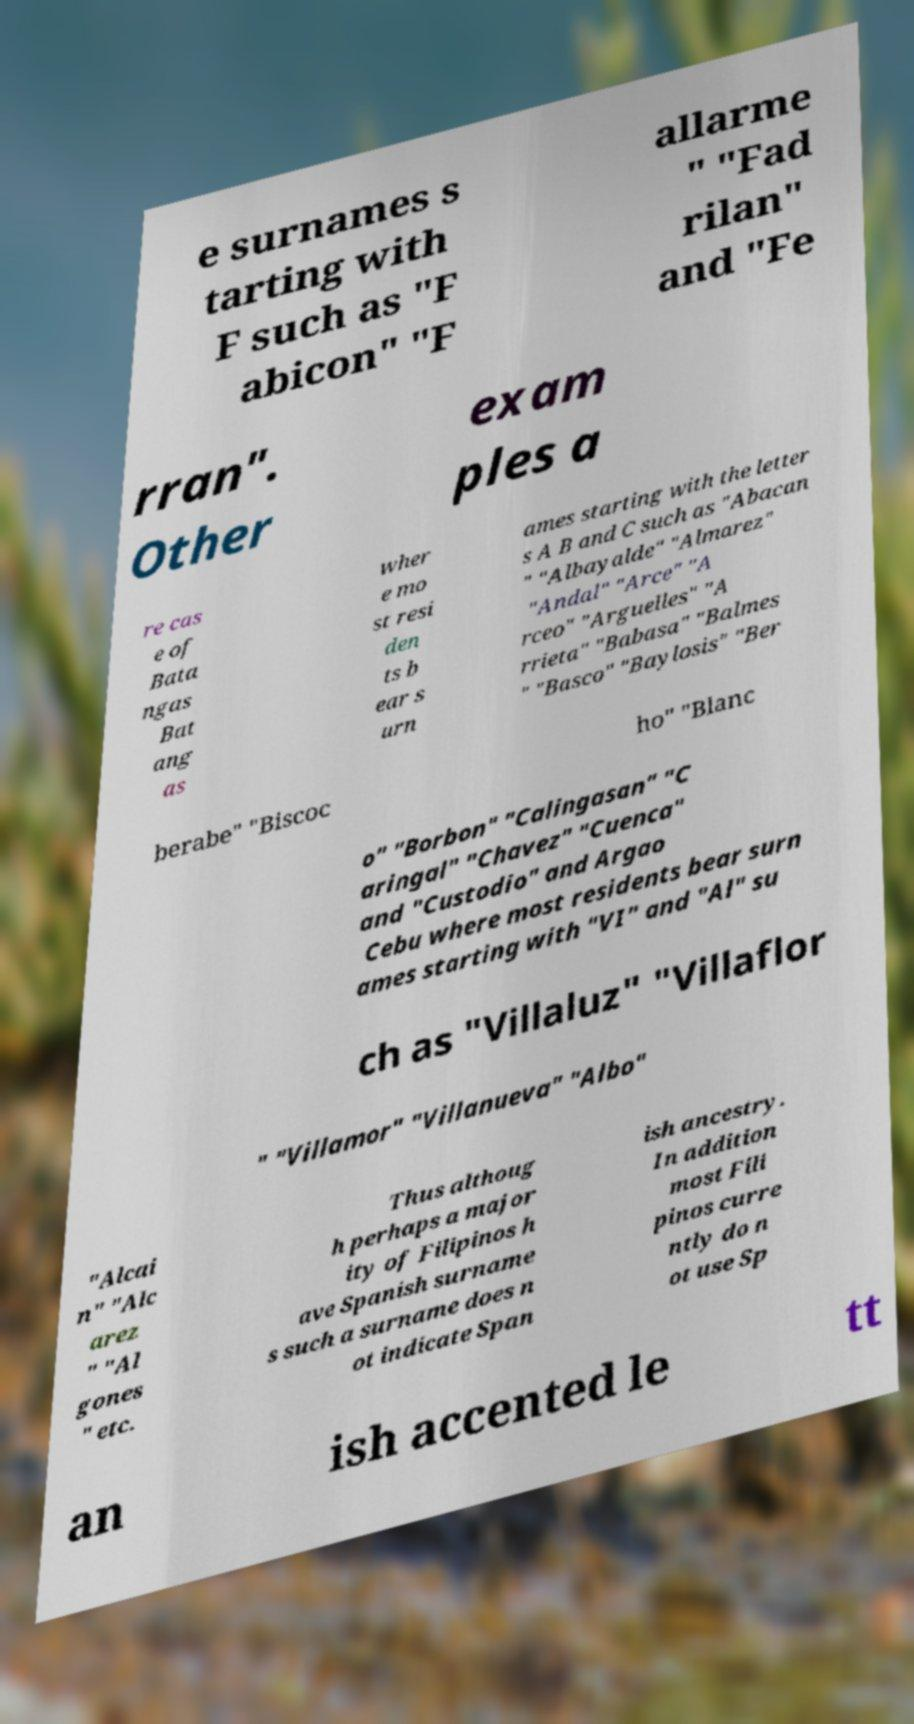For documentation purposes, I need the text within this image transcribed. Could you provide that? e surnames s tarting with F such as "F abicon" "F allarme " "Fad rilan" and "Fe rran". Other exam ples a re cas e of Bata ngas Bat ang as wher e mo st resi den ts b ear s urn ames starting with the letter s A B and C such as "Abacan " "Albayalde" "Almarez" "Andal" "Arce" "A rceo" "Arguelles" "A rrieta" "Babasa" "Balmes " "Basco" "Baylosis" "Ber berabe" "Biscoc ho" "Blanc o" "Borbon" "Calingasan" "C aringal" "Chavez" "Cuenca" and "Custodio" and Argao Cebu where most residents bear surn ames starting with "VI" and "Al" su ch as "Villaluz" "Villaflor " "Villamor" "Villanueva" "Albo" "Alcai n" "Alc arez " "Al gones " etc. Thus althoug h perhaps a major ity of Filipinos h ave Spanish surname s such a surname does n ot indicate Span ish ancestry. In addition most Fili pinos curre ntly do n ot use Sp an ish accented le tt 